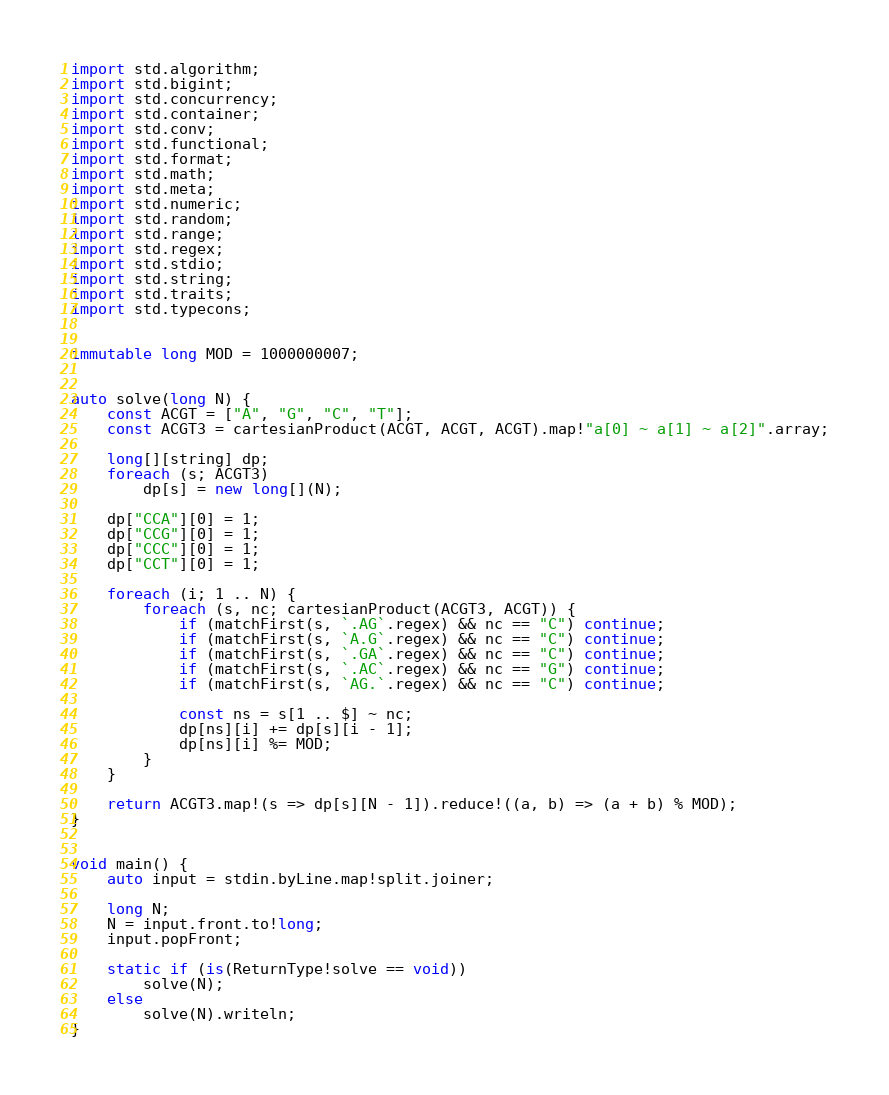<code> <loc_0><loc_0><loc_500><loc_500><_D_>import std.algorithm;
import std.bigint;
import std.concurrency;
import std.container;
import std.conv;
import std.functional;
import std.format;
import std.math;
import std.meta;
import std.numeric;
import std.random;
import std.range;
import std.regex;
import std.stdio;
import std.string;
import std.traits;
import std.typecons;


immutable long MOD = 1000000007;


auto solve(long N) {
    const ACGT = ["A", "G", "C", "T"];
    const ACGT3 = cartesianProduct(ACGT, ACGT, ACGT).map!"a[0] ~ a[1] ~ a[2]".array;

    long[][string] dp;
    foreach (s; ACGT3)
        dp[s] = new long[](N);
    
    dp["CCA"][0] = 1;
    dp["CCG"][0] = 1;
    dp["CCC"][0] = 1;
    dp["CCT"][0] = 1;

    foreach (i; 1 .. N) {
        foreach (s, nc; cartesianProduct(ACGT3, ACGT)) {
            if (matchFirst(s, `.AG`.regex) && nc == "C") continue;
            if (matchFirst(s, `A.G`.regex) && nc == "C") continue;
            if (matchFirst(s, `.GA`.regex) && nc == "C") continue;
            if (matchFirst(s, `.AC`.regex) && nc == "G") continue;
            if (matchFirst(s, `AG.`.regex) && nc == "C") continue;

            const ns = s[1 .. $] ~ nc;
            dp[ns][i] += dp[s][i - 1];
            dp[ns][i] %= MOD;
        }
    }

    return ACGT3.map!(s => dp[s][N - 1]).reduce!((a, b) => (a + b) % MOD);
}


void main() {
    auto input = stdin.byLine.map!split.joiner;

    long N;
    N = input.front.to!long;
    input.popFront;

    static if (is(ReturnType!solve == void))
        solve(N);
    else
        solve(N).writeln;
}
</code> 